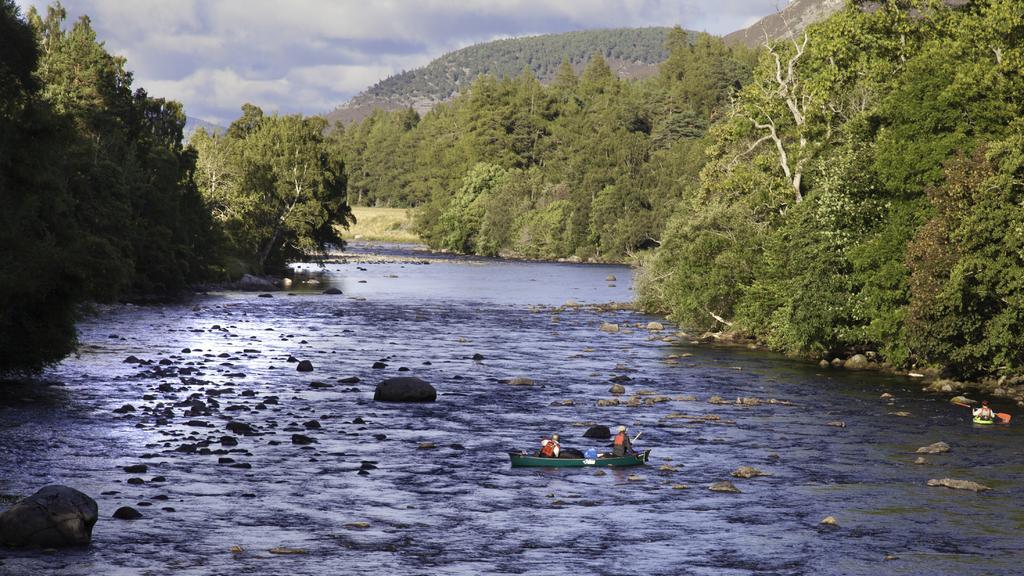Please provide a concise description of this image. In this image I can see the boat and the boat is on the water. I can see two persons sitting in the boat, background I can see few stones, trees in green color and the sky is in blue and white color. 